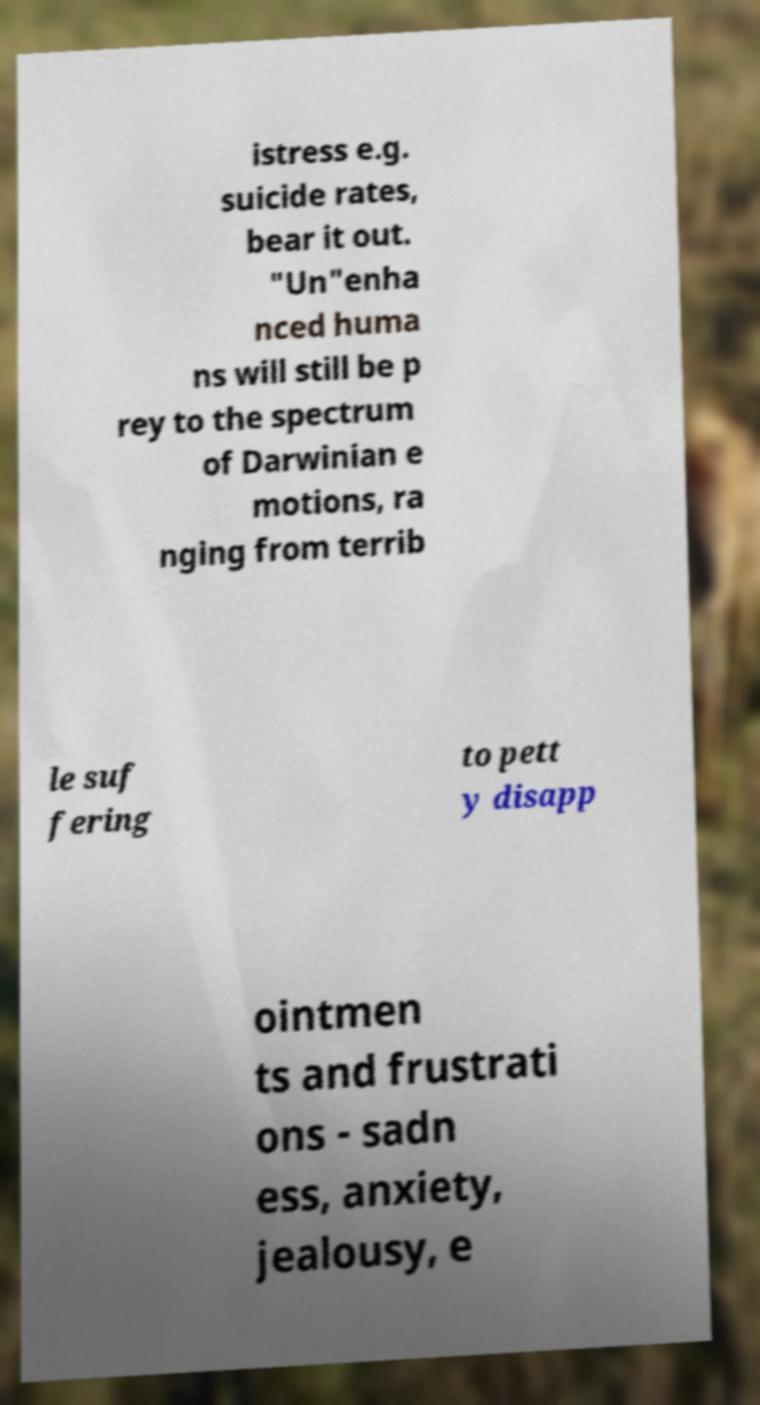Can you read and provide the text displayed in the image?This photo seems to have some interesting text. Can you extract and type it out for me? istress e.g. suicide rates, bear it out. "Un"enha nced huma ns will still be p rey to the spectrum of Darwinian e motions, ra nging from terrib le suf fering to pett y disapp ointmen ts and frustrati ons - sadn ess, anxiety, jealousy, e 